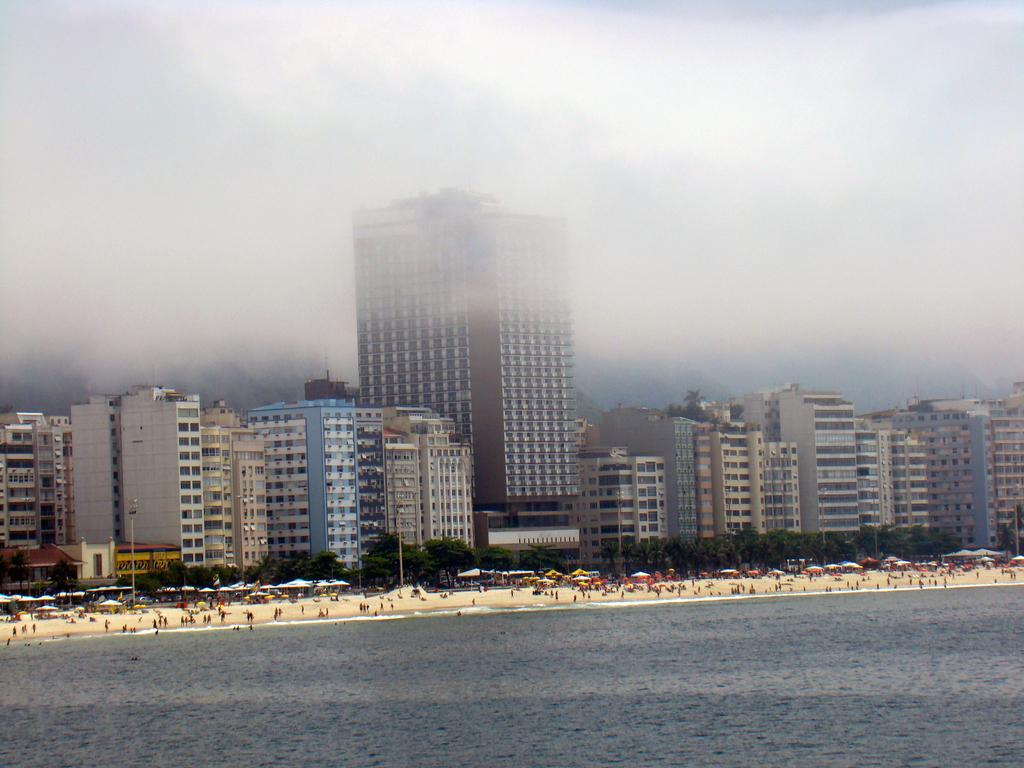What type of location is depicted in the image? There is a beach in the image. What are the people in the image doing? People are standing on the seashore. What can be seen in the distance behind the people? There are buildings visible in the background. What type of poison is being used by the jellyfish in the image? There are no jellyfish present in the image, so it is not possible to determine if any poison is being used. 